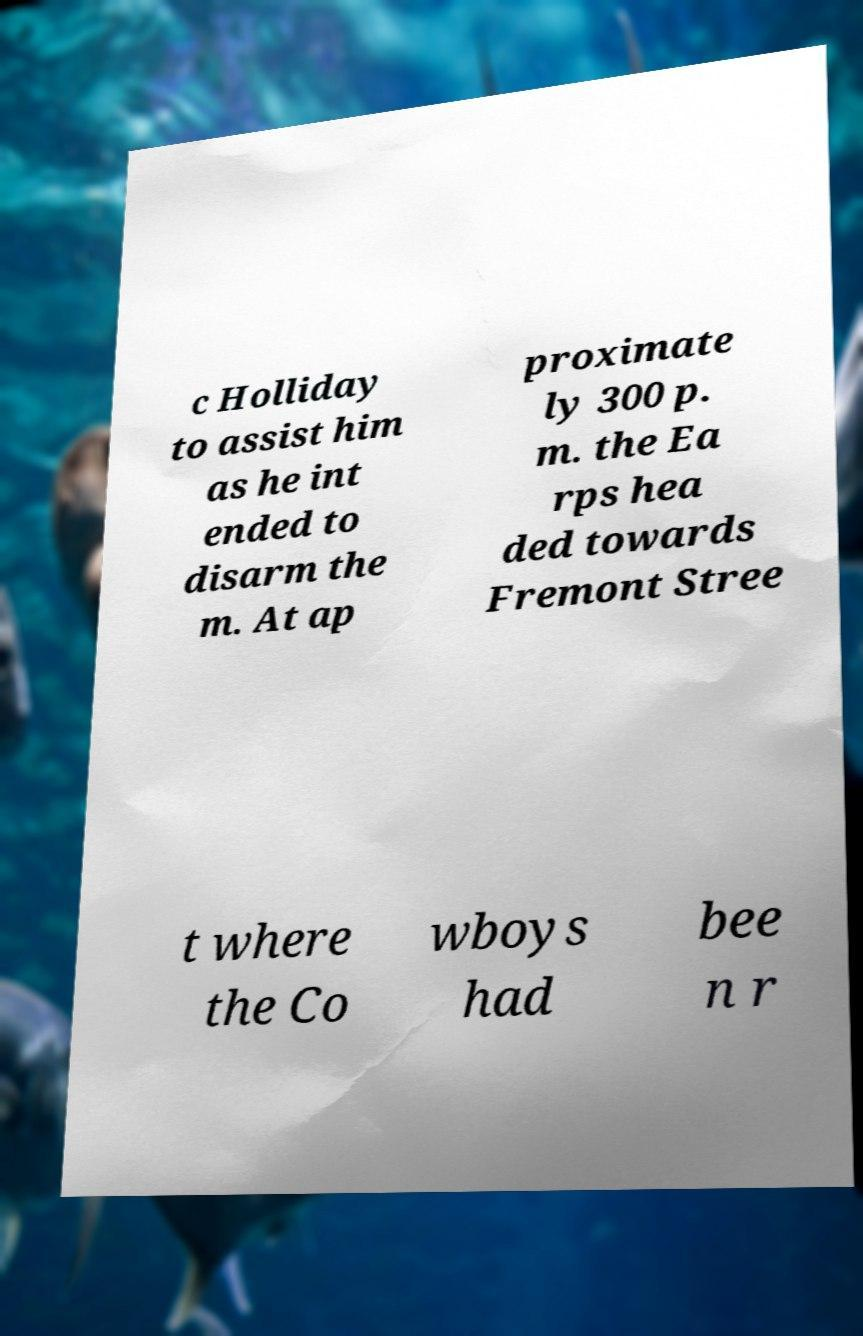Can you accurately transcribe the text from the provided image for me? c Holliday to assist him as he int ended to disarm the m. At ap proximate ly 300 p. m. the Ea rps hea ded towards Fremont Stree t where the Co wboys had bee n r 